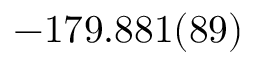Convert formula to latex. <formula><loc_0><loc_0><loc_500><loc_500>- 1 7 9 . 8 8 1 ( 8 9 )</formula> 